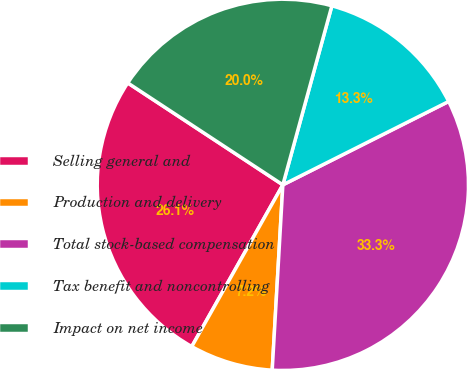<chart> <loc_0><loc_0><loc_500><loc_500><pie_chart><fcel>Selling general and<fcel>Production and delivery<fcel>Total stock-based compensation<fcel>Tax benefit and noncontrolling<fcel>Impact on net income<nl><fcel>26.09%<fcel>7.25%<fcel>33.33%<fcel>13.33%<fcel>20.0%<nl></chart> 